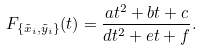Convert formula to latex. <formula><loc_0><loc_0><loc_500><loc_500>F _ { \{ \tilde { x } _ { i } , \tilde { y } _ { i } \} } ( t ) = \frac { a t ^ { 2 } + b t + c } { d t ^ { 2 } + e t + f } .</formula> 